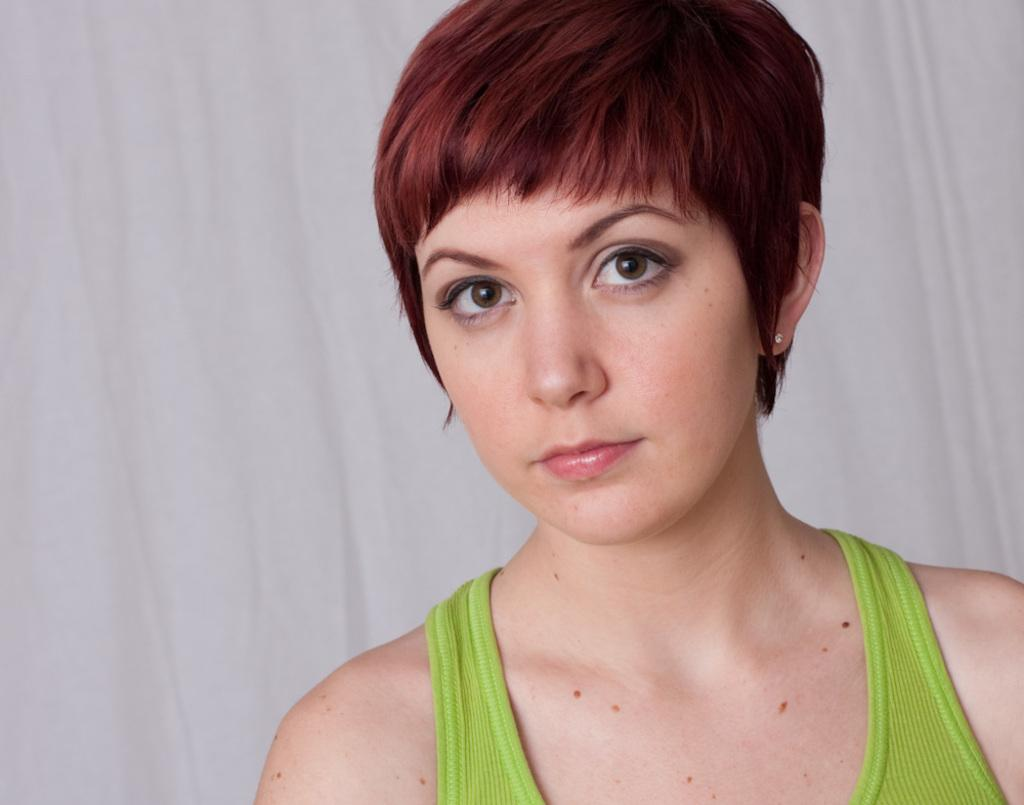Who is the main subject in the image? There is a woman in the image. What is the woman wearing? The woman is wearing a green dress. What is the color of the background in the image? The background in the image is white. Can you tell me how the stream flows in the image? There is no stream present in the image; it only features a woman wearing a green dress against a white background. 